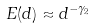Convert formula to latex. <formula><loc_0><loc_0><loc_500><loc_500>E ( d ) \approx d ^ { - \gamma _ { 2 } }</formula> 